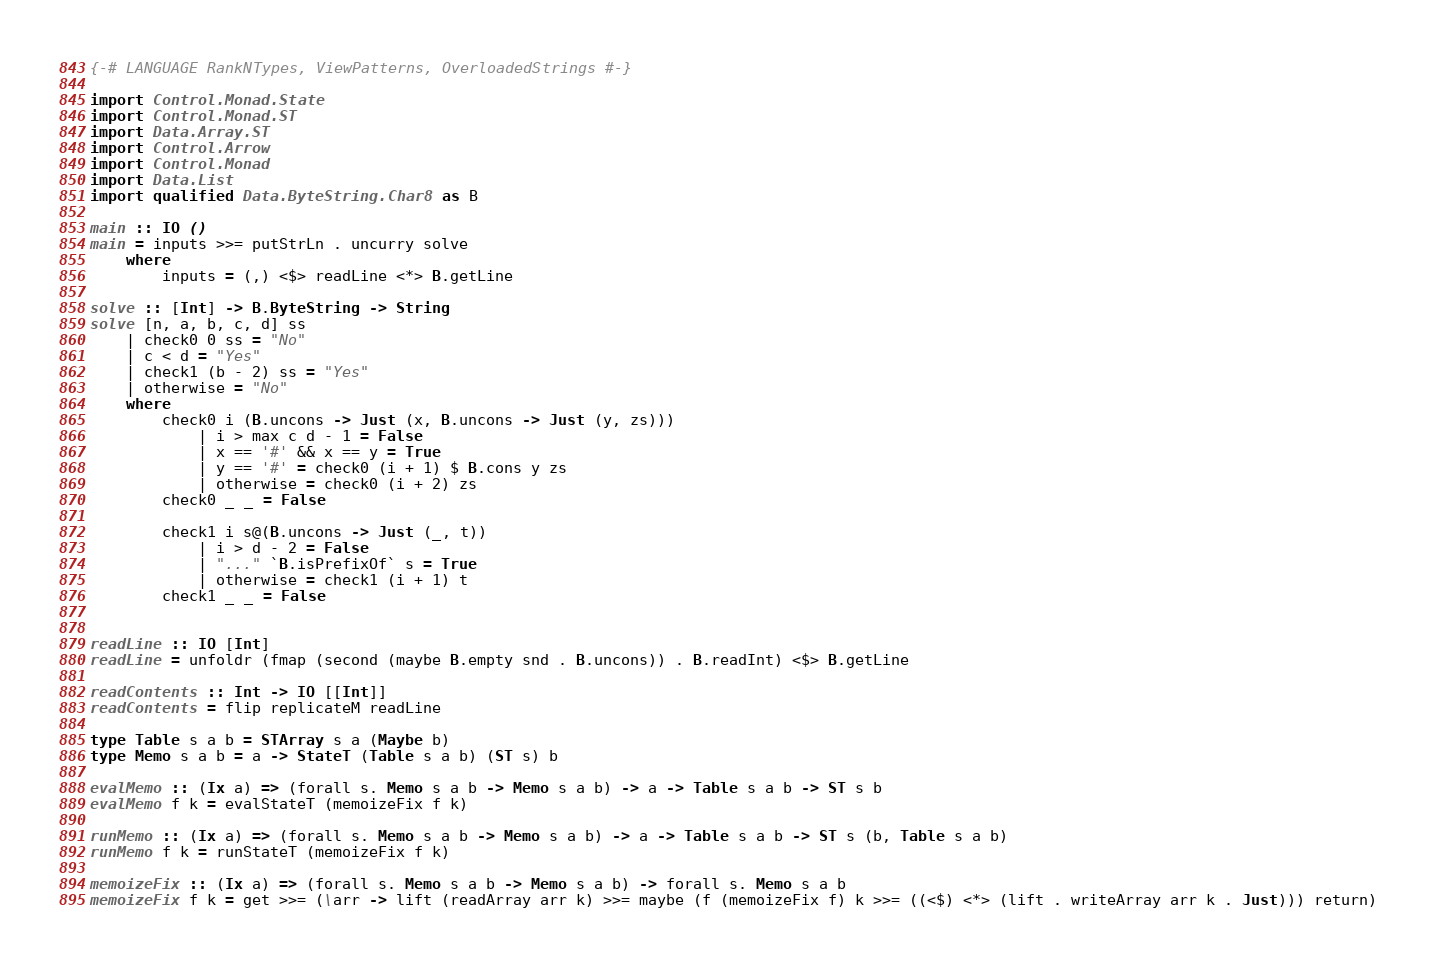Convert code to text. <code><loc_0><loc_0><loc_500><loc_500><_Haskell_>{-# LANGUAGE RankNTypes, ViewPatterns, OverloadedStrings #-}
    
import Control.Monad.State
import Control.Monad.ST
import Data.Array.ST
import Control.Arrow
import Control.Monad
import Data.List
import qualified Data.ByteString.Char8 as B

main :: IO ()
main = inputs >>= putStrLn . uncurry solve
    where
        inputs = (,) <$> readLine <*> B.getLine 

solve :: [Int] -> B.ByteString -> String
solve [n, a, b, c, d] ss 
    | check0 0 ss = "No"
    | c < d = "Yes"
    | check1 (b - 2) ss = "Yes"
    | otherwise = "No"
    where
        check0 i (B.uncons -> Just (x, B.uncons -> Just (y, zs)))
            | i > max c d - 1 = False
            | x == '#' && x == y = True 
            | y == '#' = check0 (i + 1) $ B.cons y zs
            | otherwise = check0 (i + 2) zs 
        check0 _ _ = False

        check1 i s@(B.uncons -> Just (_, t))
            | i > d - 2 = False
            | "..." `B.isPrefixOf` s = True
            | otherwise = check1 (i + 1) t
        check1 _ _ = False


readLine :: IO [Int]
readLine = unfoldr (fmap (second (maybe B.empty snd . B.uncons)) . B.readInt) <$> B.getLine

readContents :: Int -> IO [[Int]]
readContents = flip replicateM readLine

type Table s a b = STArray s a (Maybe b)
type Memo s a b = a -> StateT (Table s a b) (ST s) b

evalMemo :: (Ix a) => (forall s. Memo s a b -> Memo s a b) -> a -> Table s a b -> ST s b
evalMemo f k = evalStateT (memoizeFix f k)

runMemo :: (Ix a) => (forall s. Memo s a b -> Memo s a b) -> a -> Table s a b -> ST s (b, Table s a b)
runMemo f k = runStateT (memoizeFix f k)

memoizeFix :: (Ix a) => (forall s. Memo s a b -> Memo s a b) -> forall s. Memo s a b
memoizeFix f k = get >>= (\arr -> lift (readArray arr k) >>= maybe (f (memoizeFix f) k >>= ((<$) <*> (lift . writeArray arr k . Just))) return)</code> 